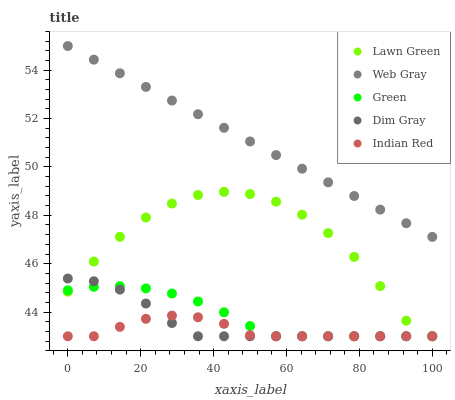Does Indian Red have the minimum area under the curve?
Answer yes or no. Yes. Does Web Gray have the maximum area under the curve?
Answer yes or no. Yes. Does Dim Gray have the minimum area under the curve?
Answer yes or no. No. Does Dim Gray have the maximum area under the curve?
Answer yes or no. No. Is Web Gray the smoothest?
Answer yes or no. Yes. Is Lawn Green the roughest?
Answer yes or no. Yes. Is Dim Gray the smoothest?
Answer yes or no. No. Is Dim Gray the roughest?
Answer yes or no. No. Does Lawn Green have the lowest value?
Answer yes or no. Yes. Does Web Gray have the lowest value?
Answer yes or no. No. Does Web Gray have the highest value?
Answer yes or no. Yes. Does Dim Gray have the highest value?
Answer yes or no. No. Is Dim Gray less than Web Gray?
Answer yes or no. Yes. Is Web Gray greater than Green?
Answer yes or no. Yes. Does Dim Gray intersect Lawn Green?
Answer yes or no. Yes. Is Dim Gray less than Lawn Green?
Answer yes or no. No. Is Dim Gray greater than Lawn Green?
Answer yes or no. No. Does Dim Gray intersect Web Gray?
Answer yes or no. No. 